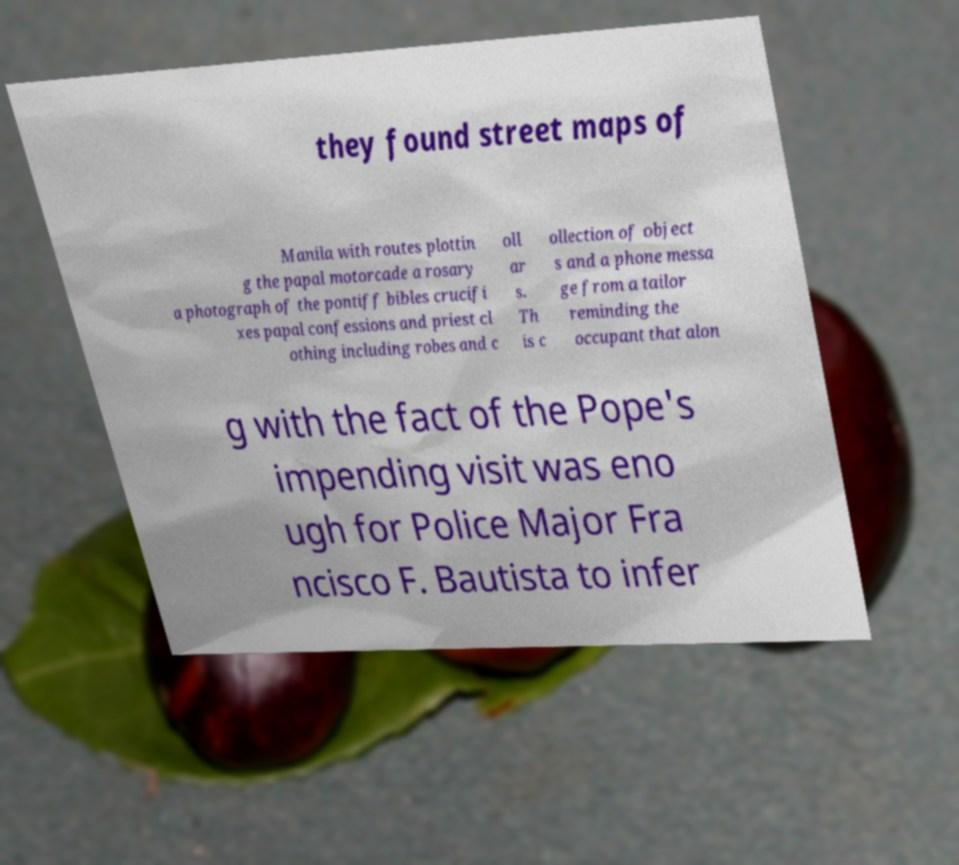Could you extract and type out the text from this image? they found street maps of Manila with routes plottin g the papal motorcade a rosary a photograph of the pontiff bibles crucifi xes papal confessions and priest cl othing including robes and c oll ar s. Th is c ollection of object s and a phone messa ge from a tailor reminding the occupant that alon g with the fact of the Pope's impending visit was eno ugh for Police Major Fra ncisco F. Bautista to infer 